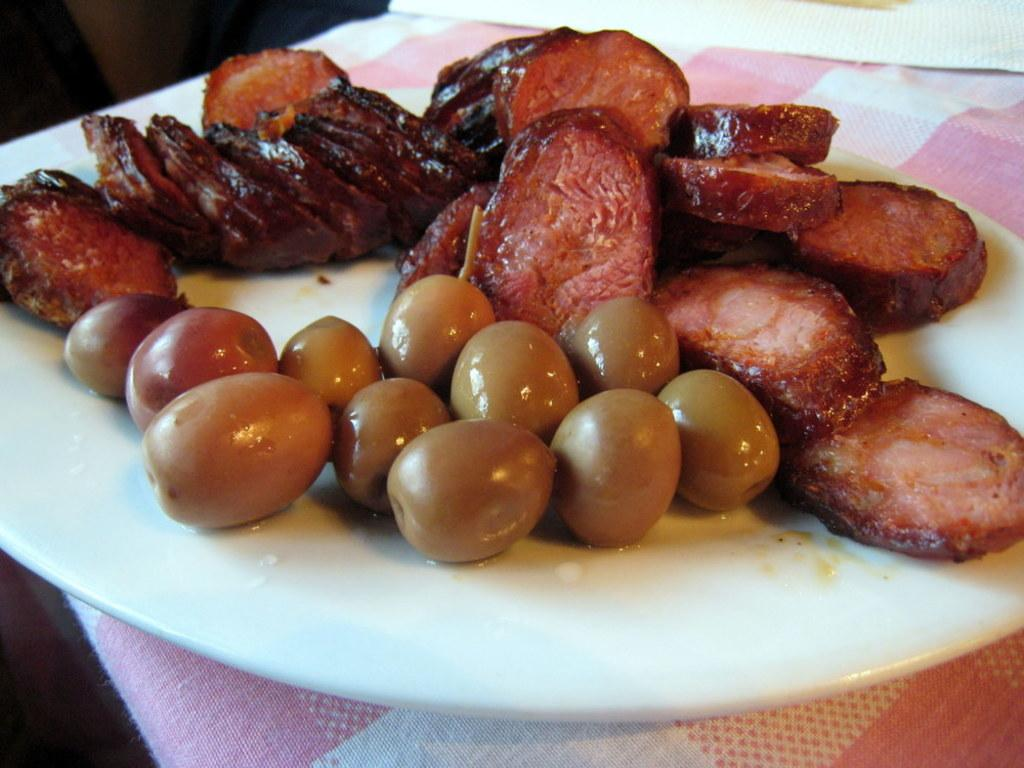What piece of furniture is present in the image? There is a table in the image. What is placed on the table? There is a plate on the table. What is on the plate? There is a food item on the plate. What year is depicted on the page in the image? There is no page present in the image, so it is not possible to determine the year depicted. 